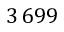<formula> <loc_0><loc_0><loc_500><loc_500>3 \, 6 9 9</formula> 